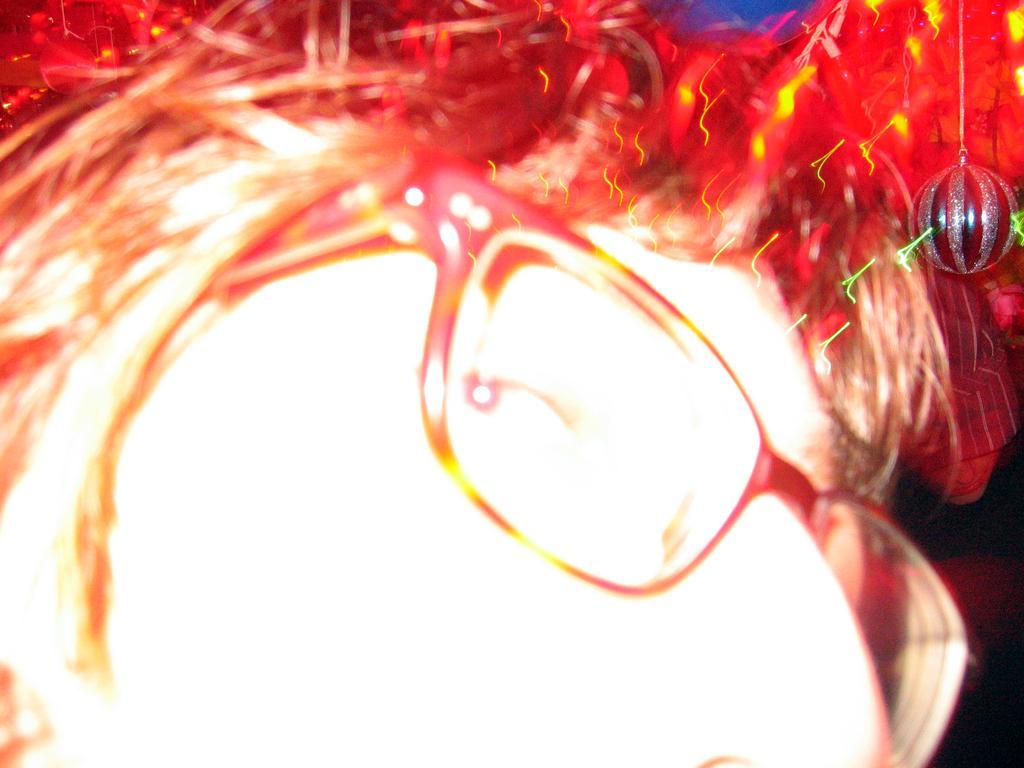Please provide a concise description of this image. This is a zoomed image. In this image we can see the face of a person. 